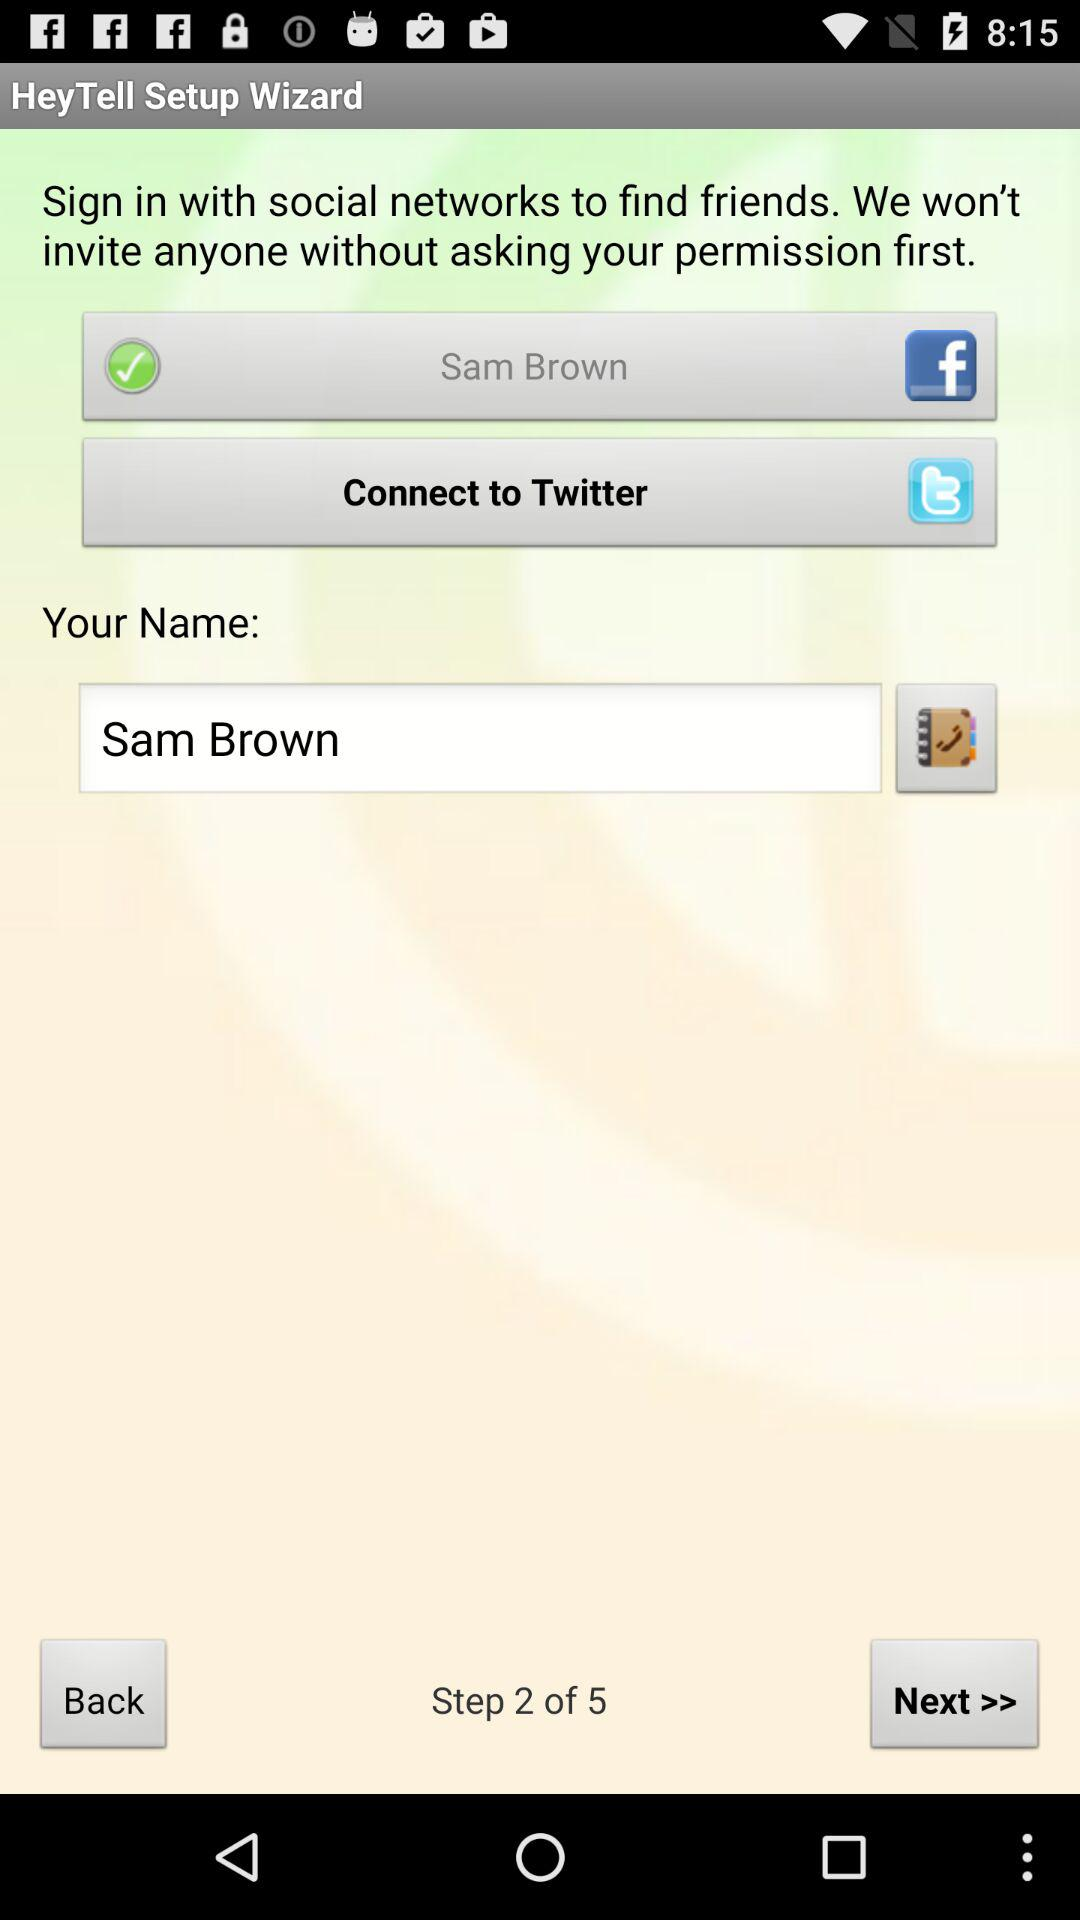How many social networks can I sign in with?
Answer the question using a single word or phrase. 2 